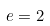<formula> <loc_0><loc_0><loc_500><loc_500>e = 2</formula> 